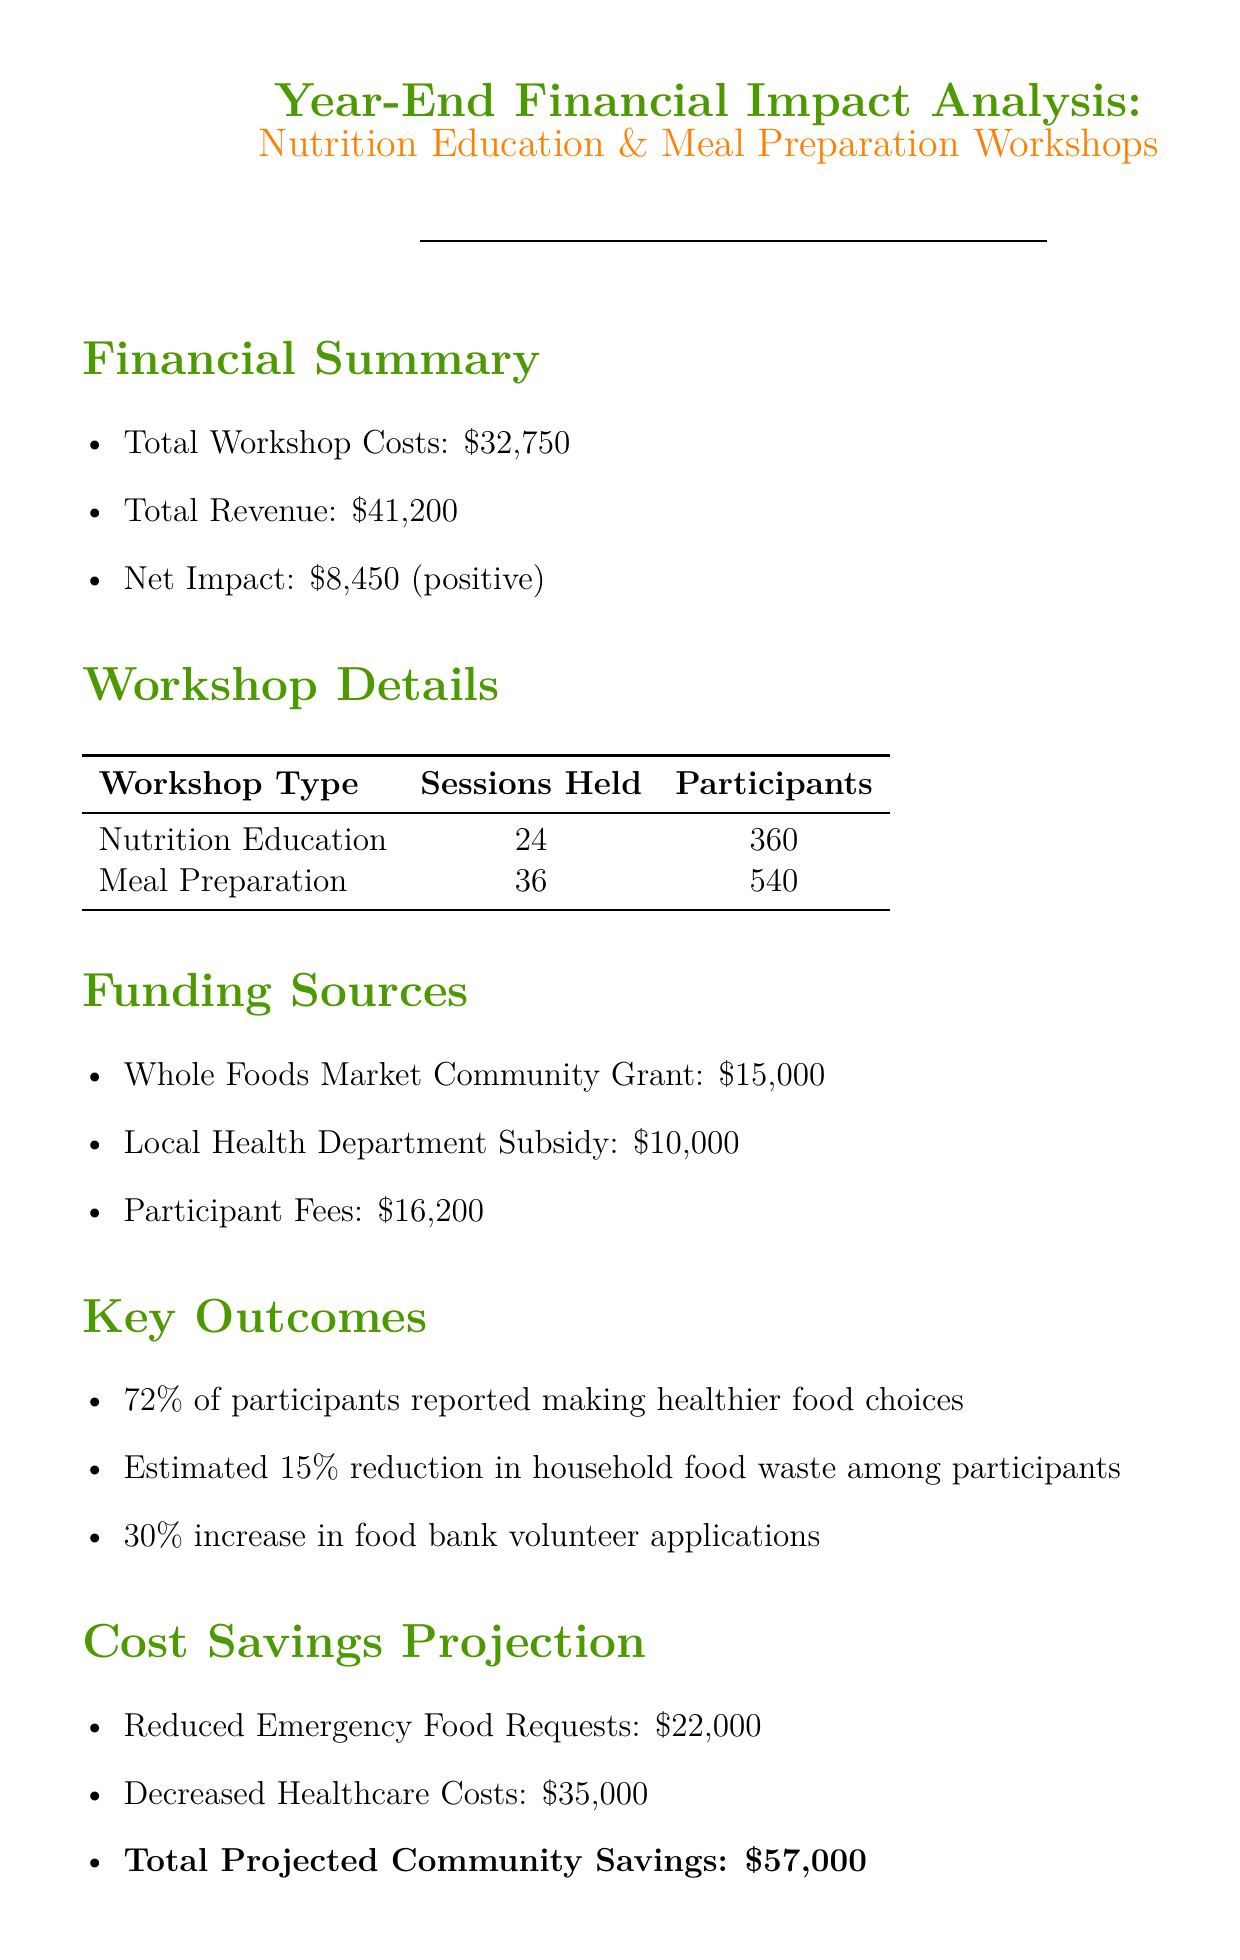What are the total workshop costs? The total workshop costs are explicitly stated in the financial summary section of the document.
Answer: $32,750 How many nutrition education sessions were held? The number of nutrition education sessions is listed under the workshop details section.
Answer: 24 What is the net impact of the workshops? The net impact is calculated by subtracting total workshop costs from total revenue, as stated in the financial summary.
Answer: $8,450 Which funding source contributed the most amount? The funding sources section lists the contributions, and "Whole Foods Market Community Grant" is the highest.
Answer: Whole Foods Market Community Grant What percentage of participants reported making healthier food choices? This statistic is highlighted in the key outcomes section, indicating participant self-reported improvements.
Answer: 72% How much is the total projected community savings? The total projected community savings is mentioned in the cost savings projection section, providing a key financial metric of the workshops' impact.
Answer: $57,000 What is one recommendation made for future workshops? Recommendations for future activities are provided in the recommendations section, and one can be selected as an example of improvement.
Answer: Expand meal preparation workshops What reduction in household food waste was estimated among participants? The estimated reduction is stated in the key outcomes section related to food waste behavior changes.
Answer: 15% How many participants were involved in meal preparation workshops? The number of participants for meal preparation is provided in the workshop details section of the document.
Answer: 540 